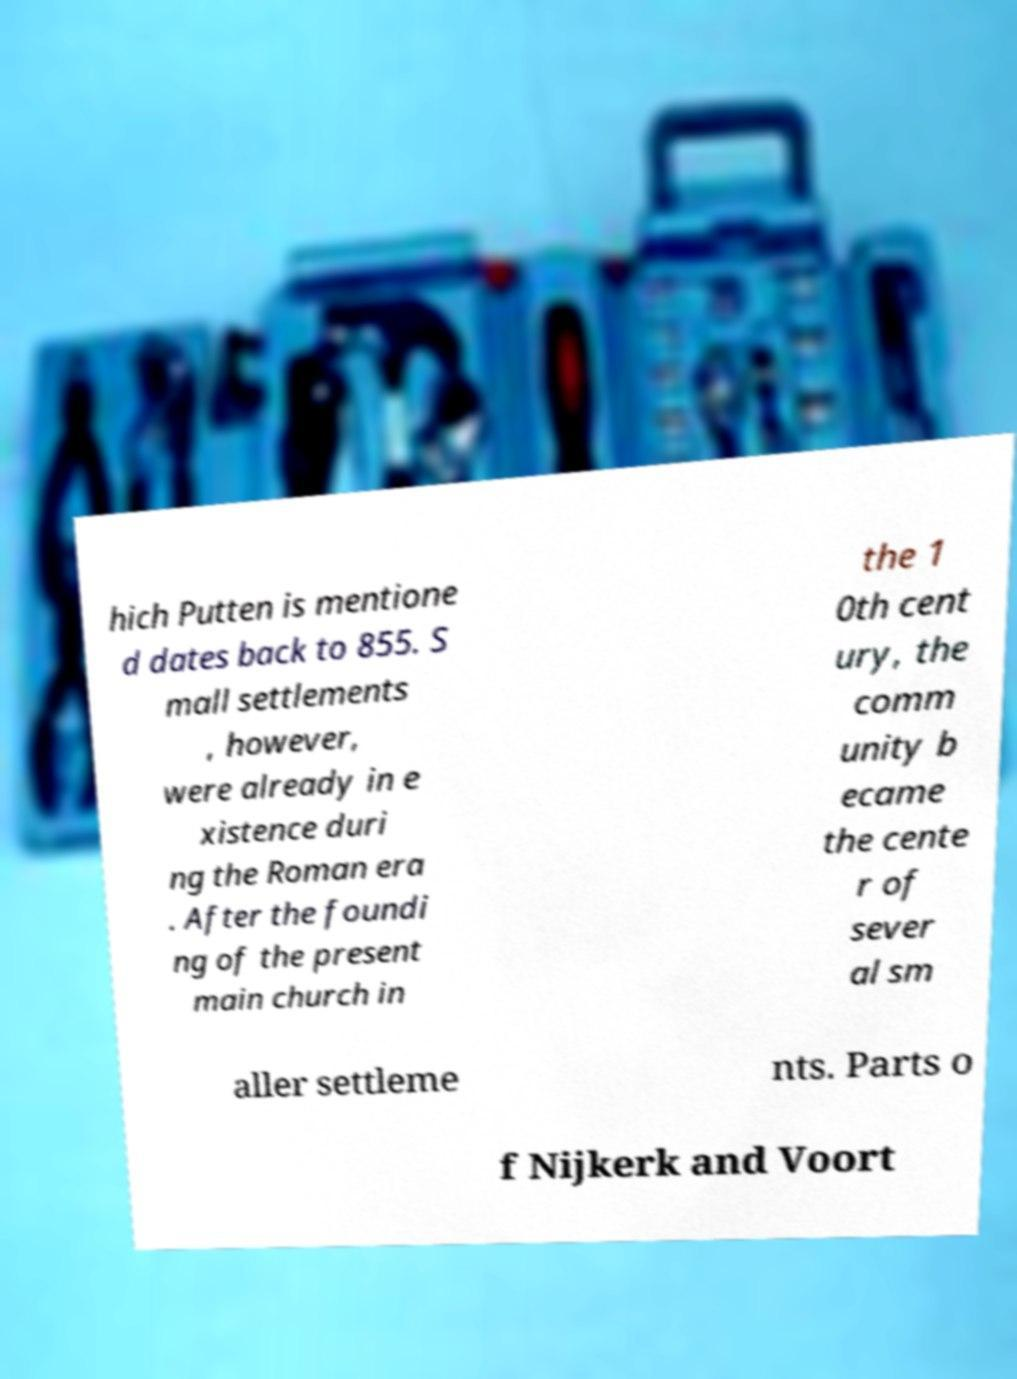For documentation purposes, I need the text within this image transcribed. Could you provide that? hich Putten is mentione d dates back to 855. S mall settlements , however, were already in e xistence duri ng the Roman era . After the foundi ng of the present main church in the 1 0th cent ury, the comm unity b ecame the cente r of sever al sm aller settleme nts. Parts o f Nijkerk and Voort 